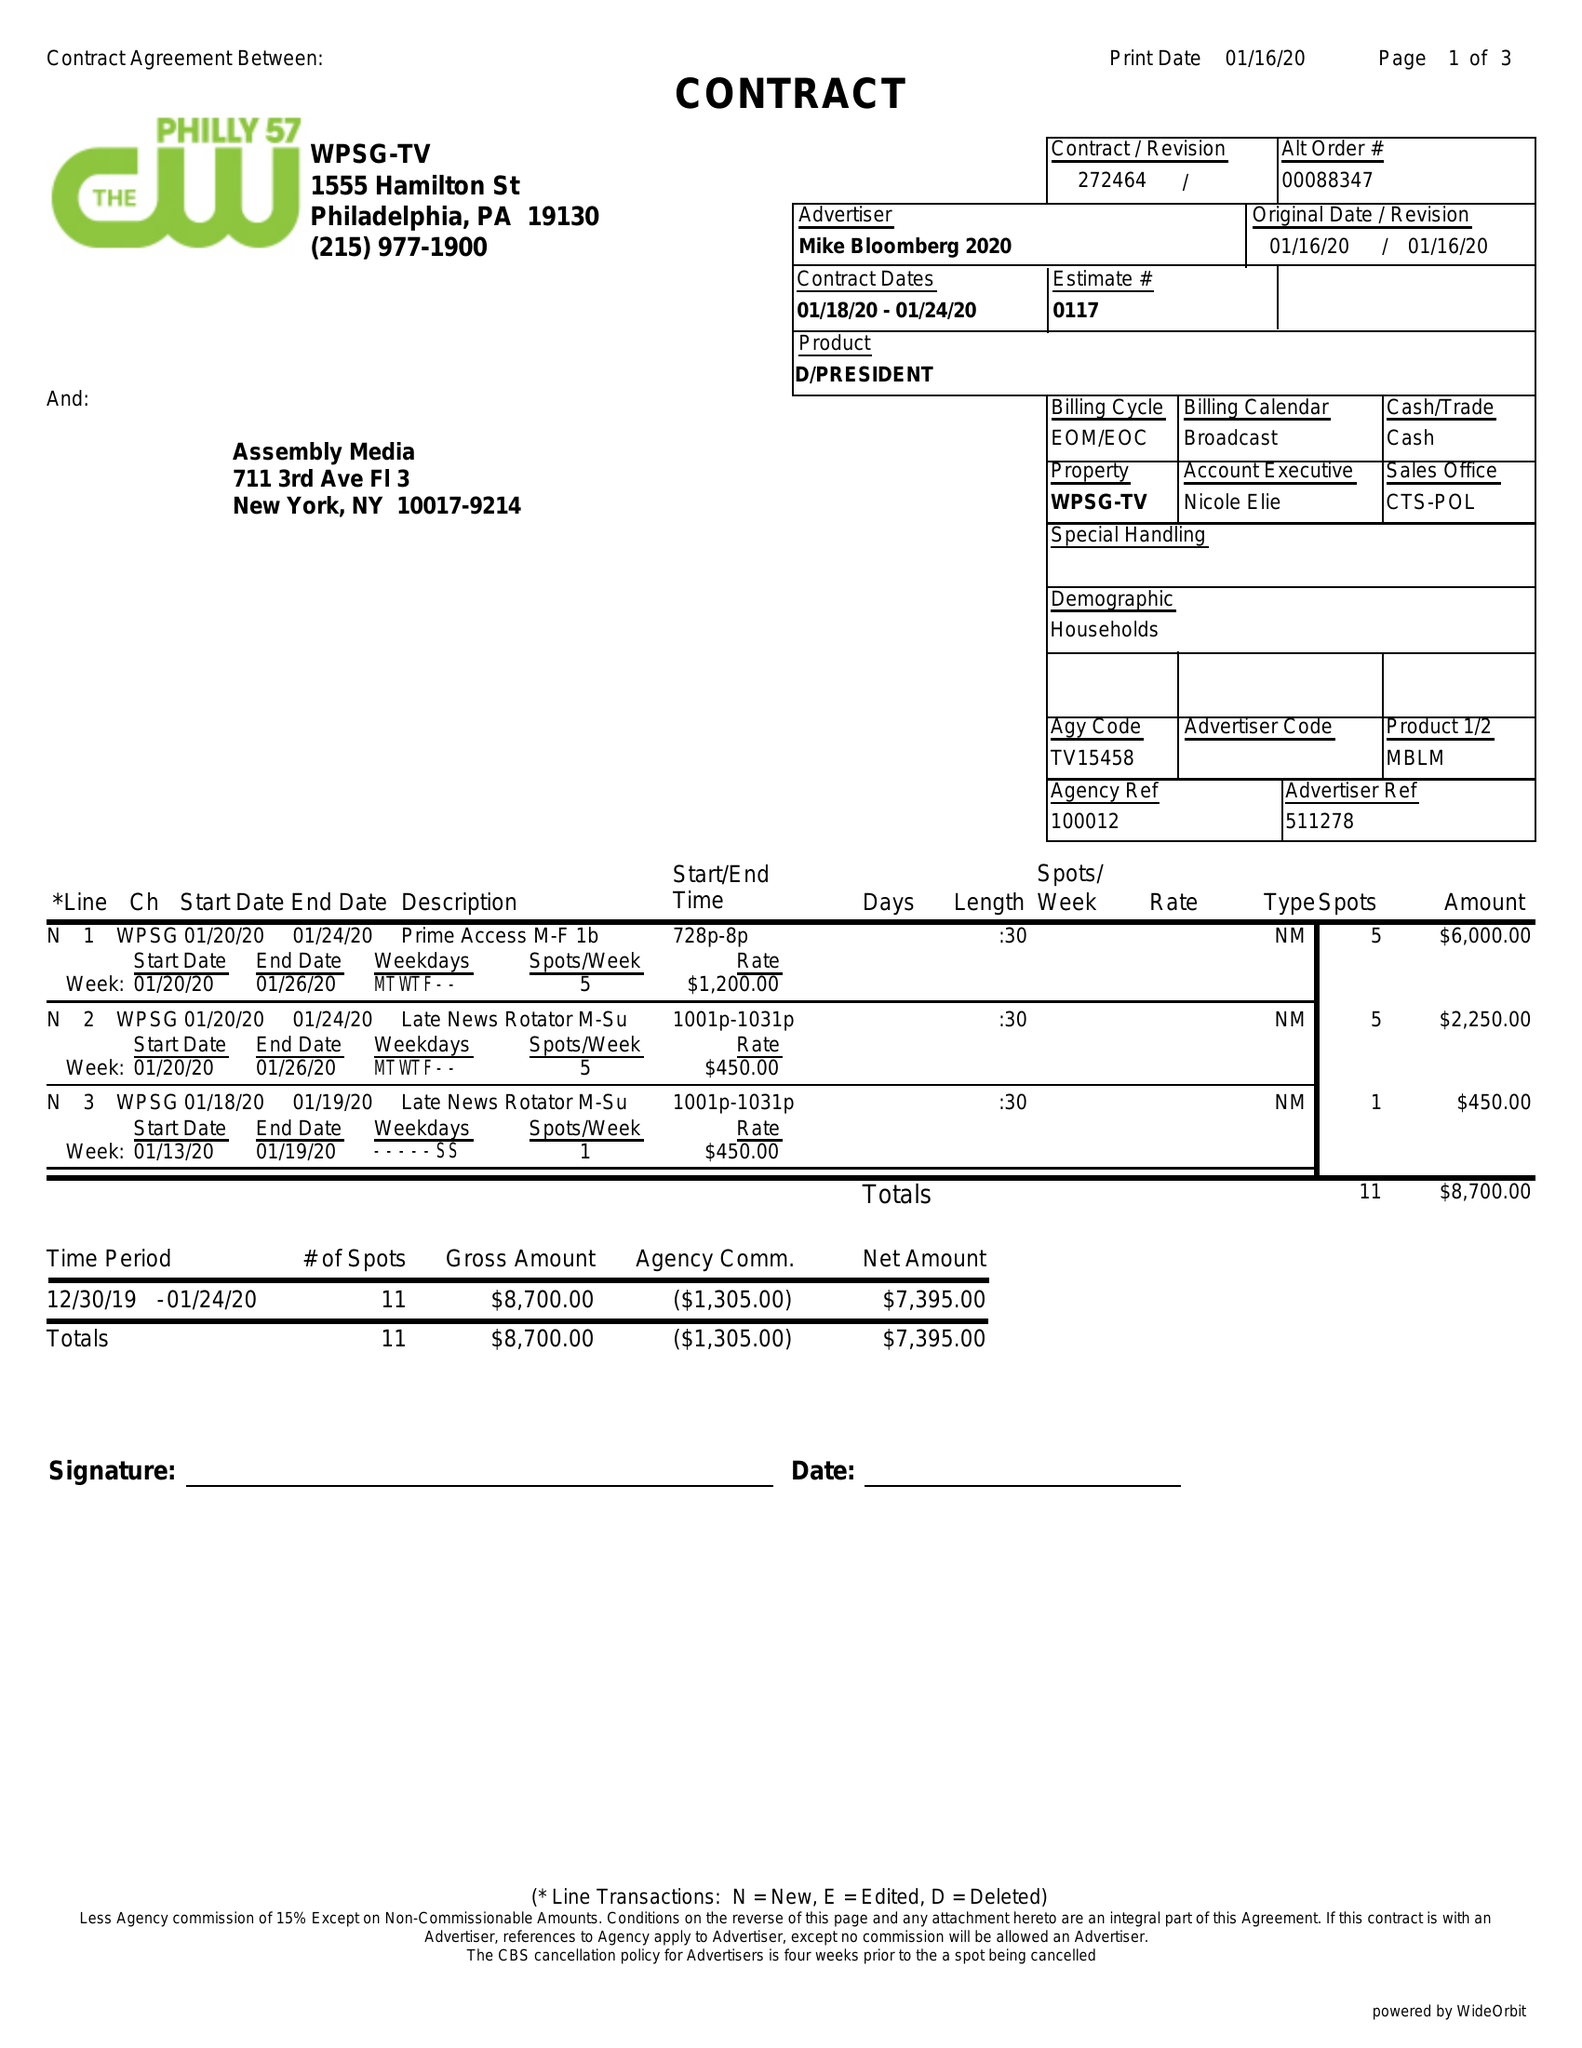What is the value for the flight_from?
Answer the question using a single word or phrase. 01/18/20 